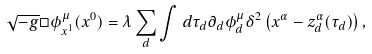Convert formula to latex. <formula><loc_0><loc_0><loc_500><loc_500>\sqrt { - g } \Box \phi ^ { \mu } _ { x ^ { 1 } } ( x ^ { 0 } ) = \lambda \sum _ { d } \int d \tau _ { d } \partial _ { d } \phi ^ { \mu } _ { d } \delta ^ { 2 } \left ( x ^ { \alpha } - z ^ { \alpha } _ { d } ( \tau _ { d } ) \right ) ,</formula> 